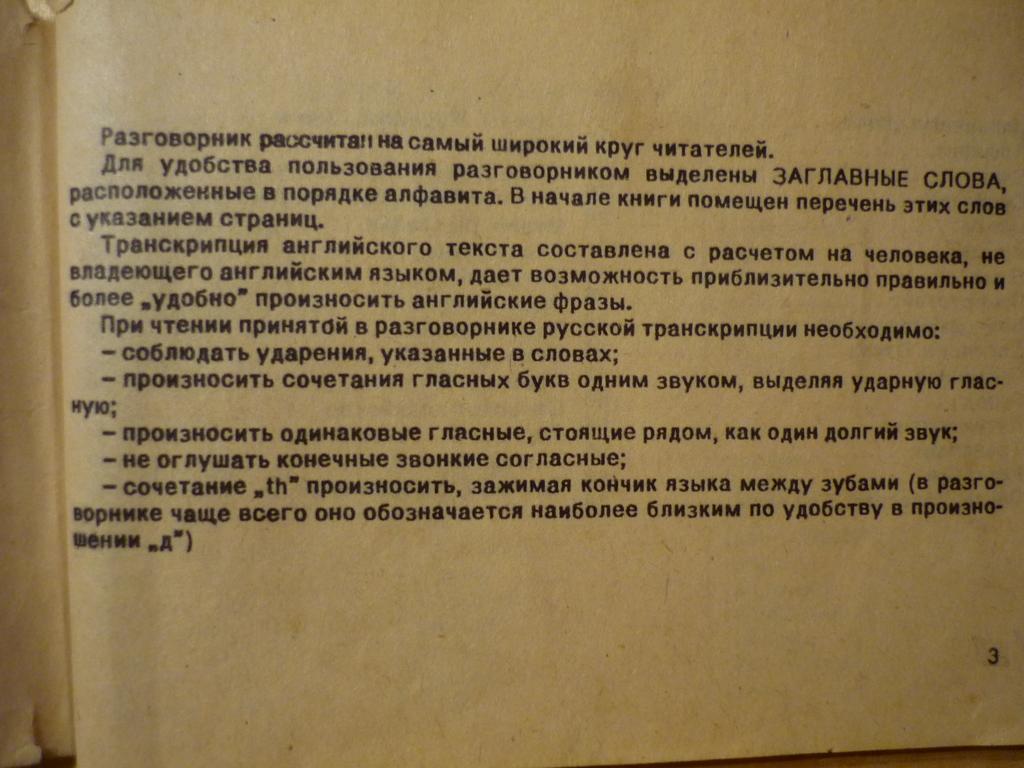What is the page number on the bottom right?
Provide a succinct answer. 3. 